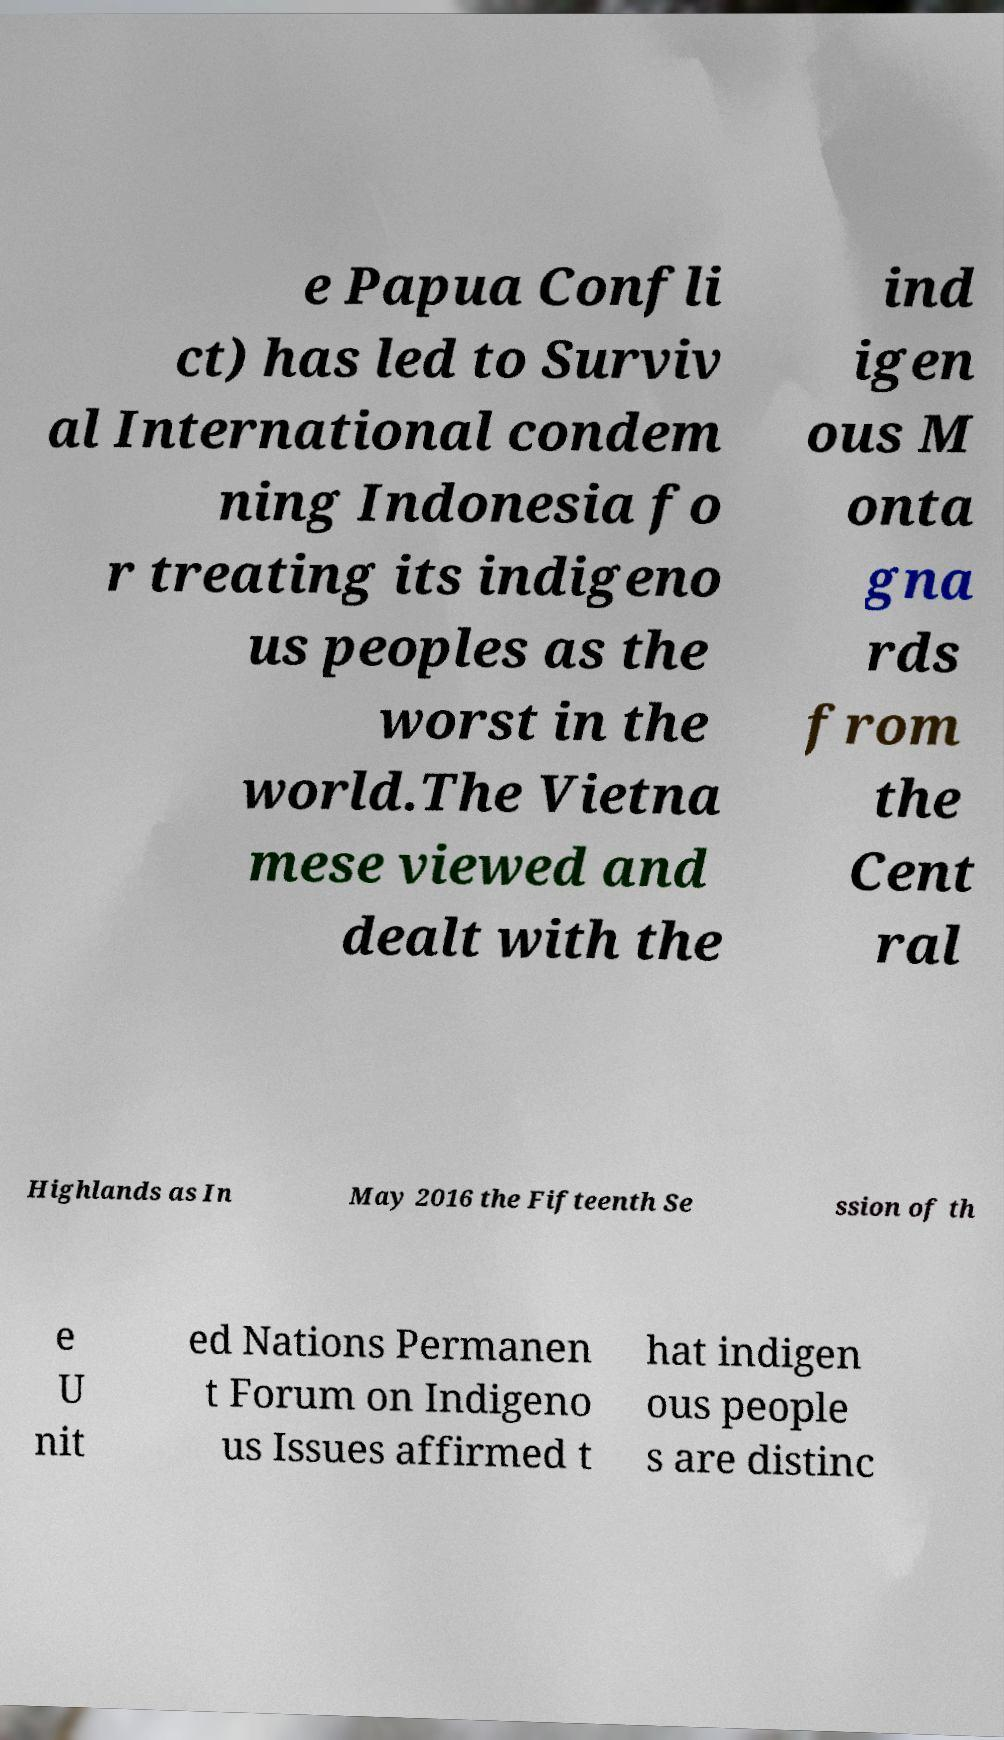I need the written content from this picture converted into text. Can you do that? e Papua Confli ct) has led to Surviv al International condem ning Indonesia fo r treating its indigeno us peoples as the worst in the world.The Vietna mese viewed and dealt with the ind igen ous M onta gna rds from the Cent ral Highlands as In May 2016 the Fifteenth Se ssion of th e U nit ed Nations Permanen t Forum on Indigeno us Issues affirmed t hat indigen ous people s are distinc 